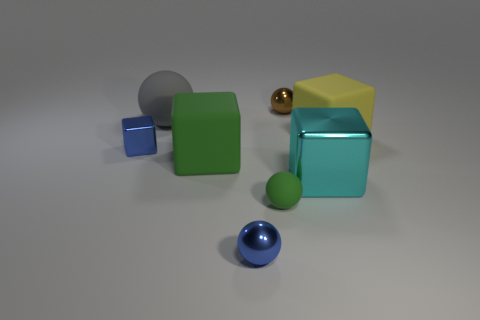Subtract all brown cubes. Subtract all red spheres. How many cubes are left? 4 Add 1 blue shiny objects. How many objects exist? 9 Subtract 0 red cylinders. How many objects are left? 8 Subtract all cyan metal objects. Subtract all large metal things. How many objects are left? 6 Add 3 yellow things. How many yellow things are left? 4 Add 1 tiny green metallic spheres. How many tiny green metallic spheres exist? 1 